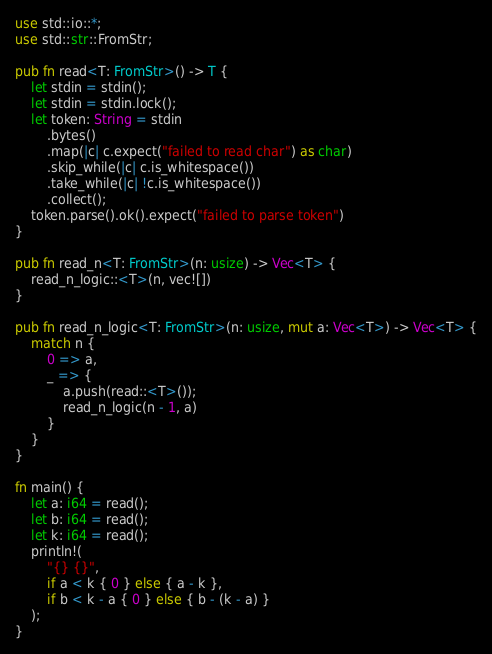<code> <loc_0><loc_0><loc_500><loc_500><_Rust_>use std::io::*;
use std::str::FromStr;

pub fn read<T: FromStr>() -> T {
    let stdin = stdin();
    let stdin = stdin.lock();
    let token: String = stdin
        .bytes()
        .map(|c| c.expect("failed to read char") as char)
        .skip_while(|c| c.is_whitespace())
        .take_while(|c| !c.is_whitespace())
        .collect();
    token.parse().ok().expect("failed to parse token")
}

pub fn read_n<T: FromStr>(n: usize) -> Vec<T> {
    read_n_logic::<T>(n, vec![])
}

pub fn read_n_logic<T: FromStr>(n: usize, mut a: Vec<T>) -> Vec<T> {
    match n {
        0 => a,
        _ => {
            a.push(read::<T>());
            read_n_logic(n - 1, a)
        }
    }
}

fn main() {
    let a: i64 = read();
    let b: i64 = read();
    let k: i64 = read();
    println!(
        "{} {}",
        if a < k { 0 } else { a - k },
        if b < k - a { 0 } else { b - (k - a) }
    );
}
</code> 